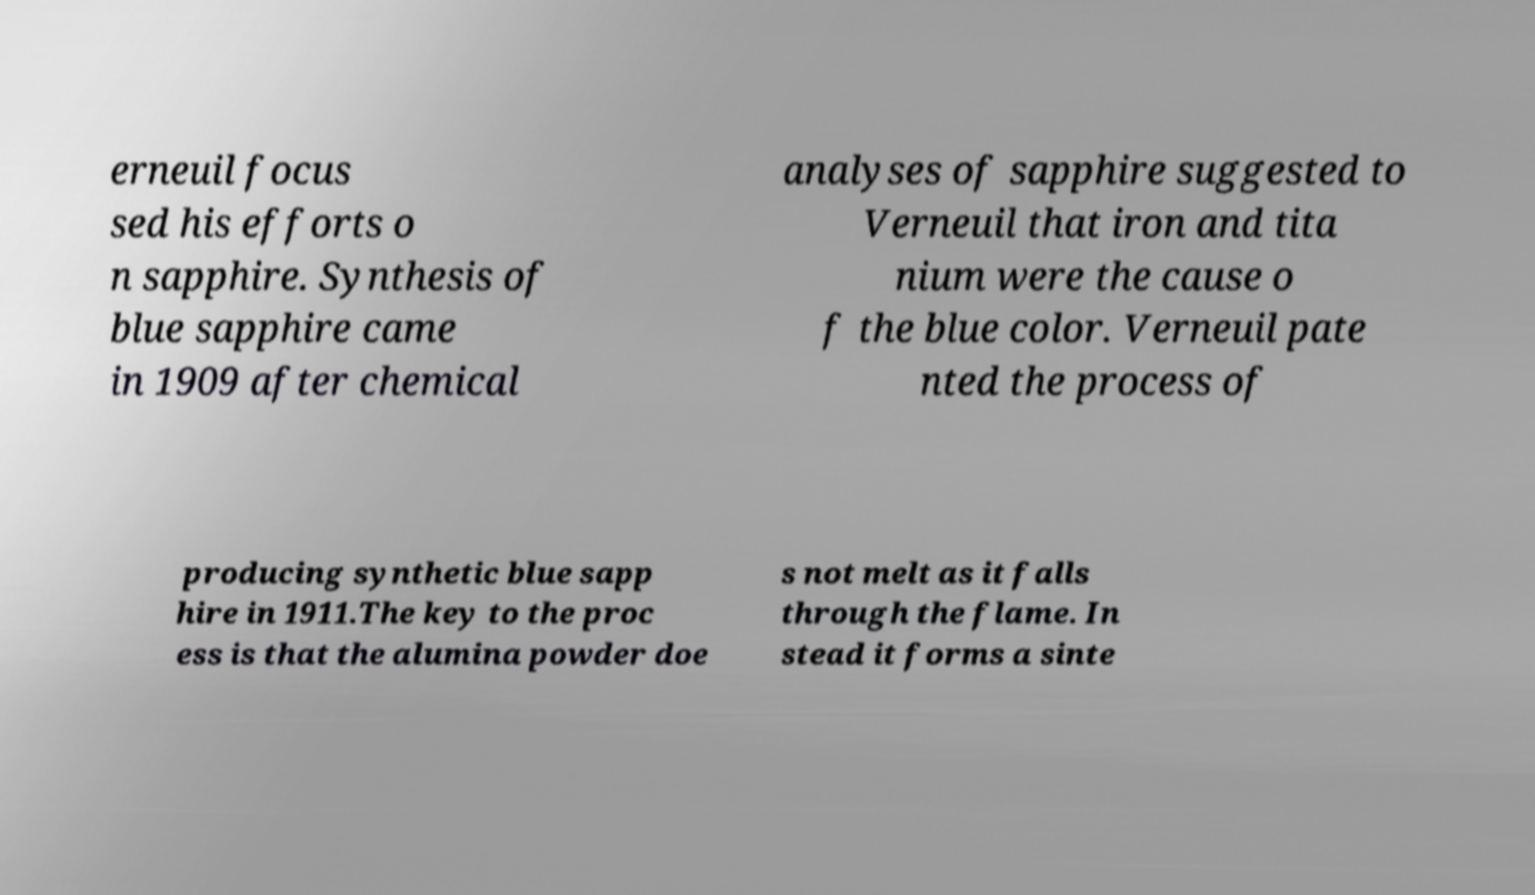Could you extract and type out the text from this image? erneuil focus sed his efforts o n sapphire. Synthesis of blue sapphire came in 1909 after chemical analyses of sapphire suggested to Verneuil that iron and tita nium were the cause o f the blue color. Verneuil pate nted the process of producing synthetic blue sapp hire in 1911.The key to the proc ess is that the alumina powder doe s not melt as it falls through the flame. In stead it forms a sinte 